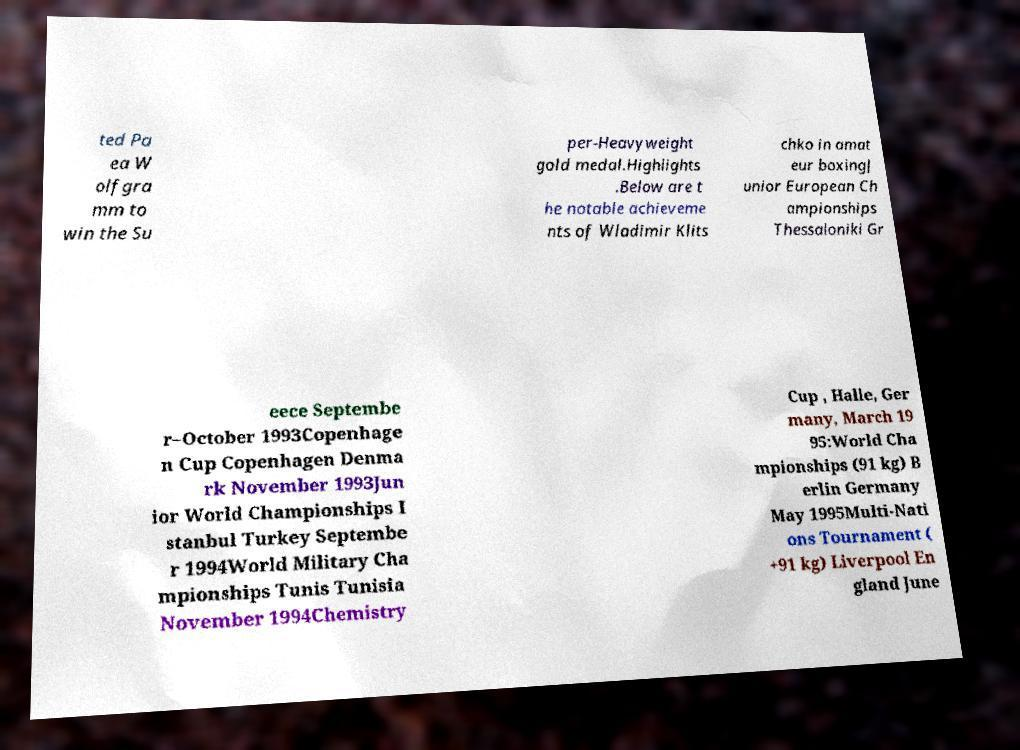Can you read and provide the text displayed in the image?This photo seems to have some interesting text. Can you extract and type it out for me? ted Pa ea W olfgra mm to win the Su per-Heavyweight gold medal.Highlights .Below are t he notable achieveme nts of Wladimir Klits chko in amat eur boxingJ unior European Ch ampionships Thessaloniki Gr eece Septembe r–October 1993Copenhage n Cup Copenhagen Denma rk November 1993Jun ior World Championships I stanbul Turkey Septembe r 1994World Military Cha mpionships Tunis Tunisia November 1994Chemistry Cup , Halle, Ger many, March 19 95:World Cha mpionships (91 kg) B erlin Germany May 1995Multi-Nati ons Tournament ( +91 kg) Liverpool En gland June 